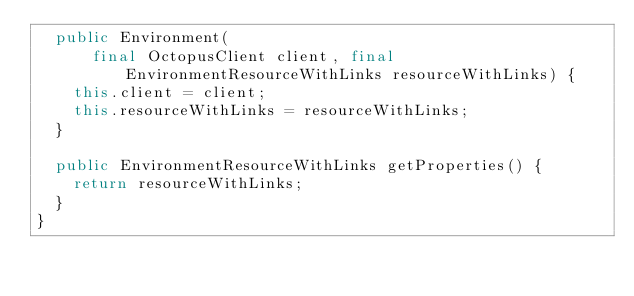<code> <loc_0><loc_0><loc_500><loc_500><_Java_>  public Environment(
      final OctopusClient client, final EnvironmentResourceWithLinks resourceWithLinks) {
    this.client = client;
    this.resourceWithLinks = resourceWithLinks;
  }

  public EnvironmentResourceWithLinks getProperties() {
    return resourceWithLinks;
  }
}
</code> 